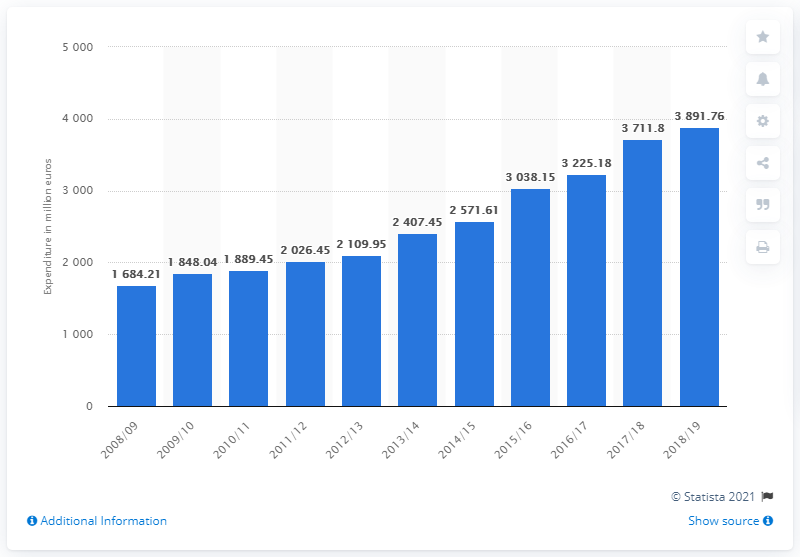List a handful of essential elements in this visual. The total expenditure of the German Bundesliga in the 2018/19 season was 3891.76. 